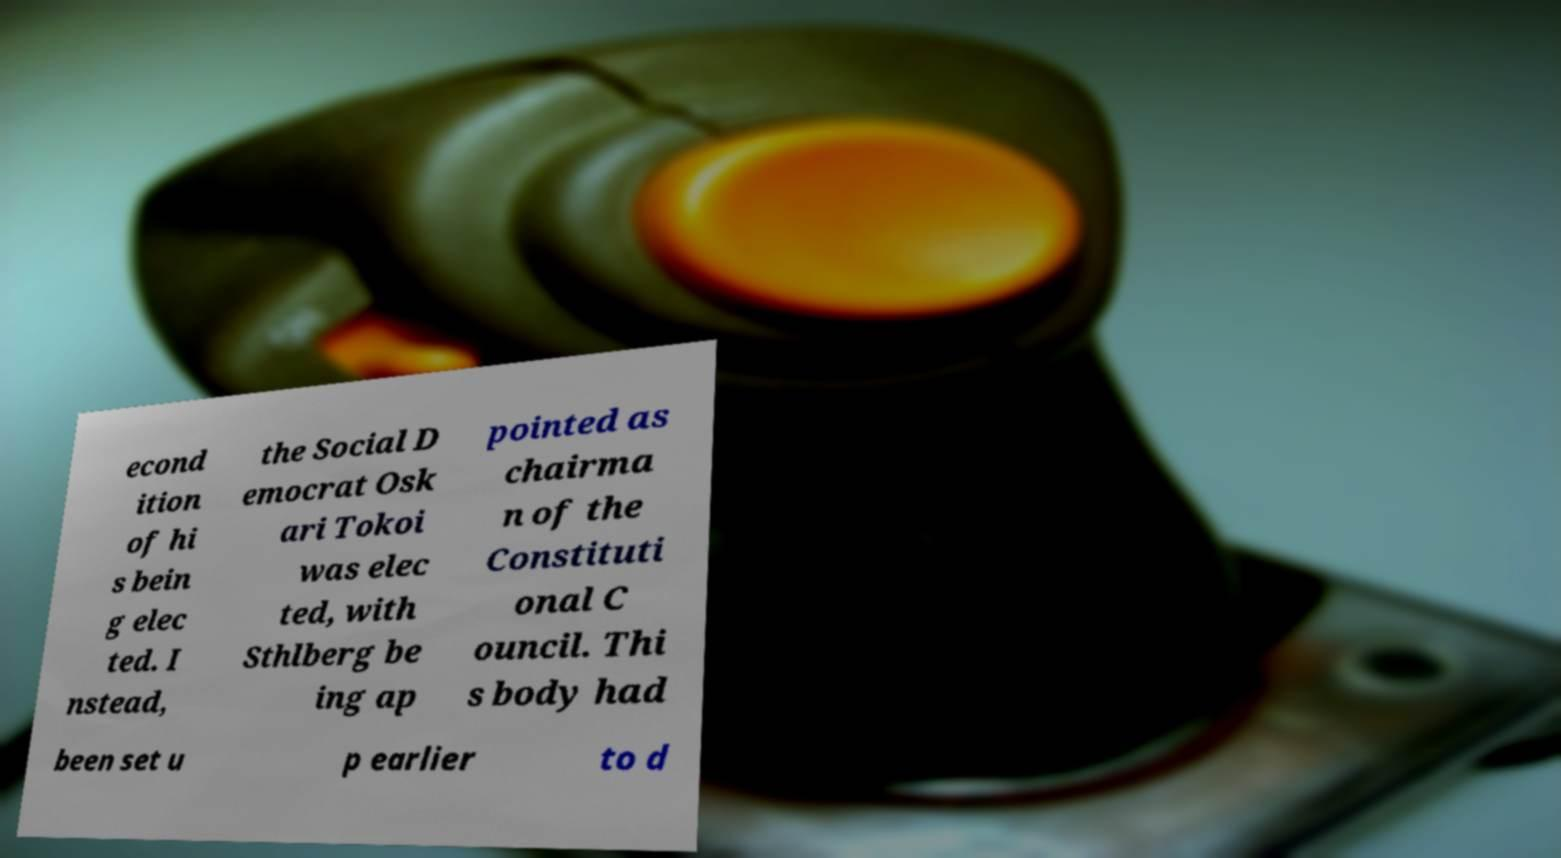There's text embedded in this image that I need extracted. Can you transcribe it verbatim? econd ition of hi s bein g elec ted. I nstead, the Social D emocrat Osk ari Tokoi was elec ted, with Sthlberg be ing ap pointed as chairma n of the Constituti onal C ouncil. Thi s body had been set u p earlier to d 